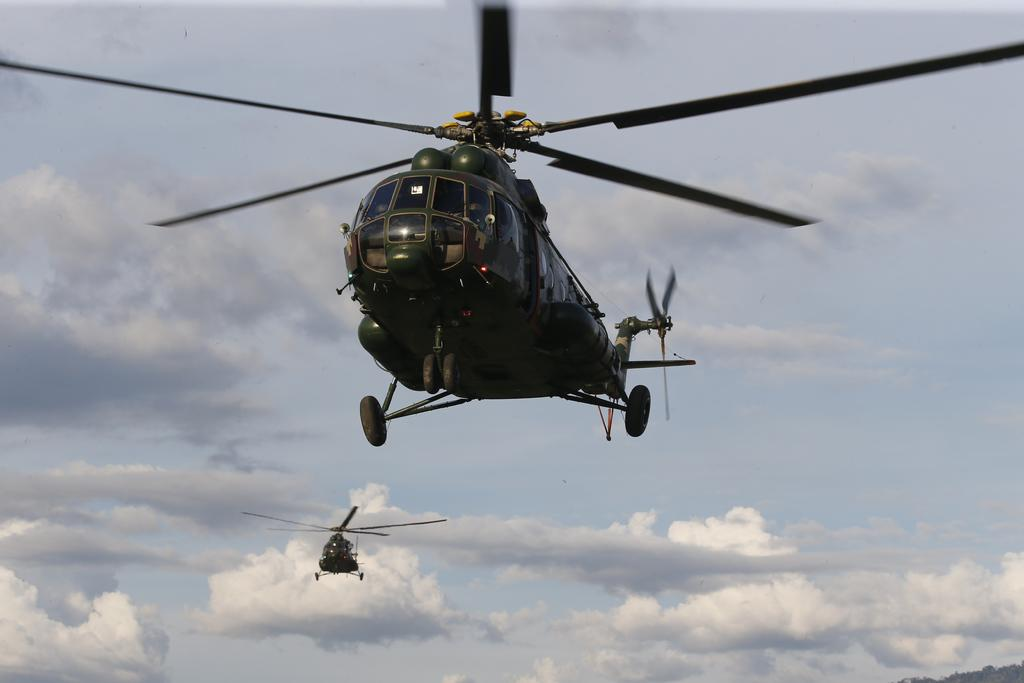What can be seen flying in the sky in the image? There are helicopters in the sky in the image. What else can be seen in the sky besides the helicopters? There are clouds visible in the image. What type of sofa is depicted in the image? There is no sofa present in the image; it only features helicopters in the sky and clouds. 